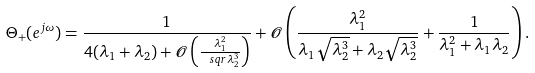Convert formula to latex. <formula><loc_0><loc_0><loc_500><loc_500>\Theta _ { + } ( e ^ { j \omega } ) = \frac { 1 } { 4 ( \lambda _ { 1 } + \lambda _ { 2 } ) + \mathcal { O } \left ( \frac { \lambda _ { 1 } ^ { 2 } } { \ s q r { \lambda _ { 2 } ^ { 3 } } } \right ) } + \mathcal { O } \left ( \frac { \lambda _ { 1 } ^ { 2 } } { \lambda _ { 1 } \sqrt { \lambda _ { 2 } ^ { 3 } } + \lambda _ { 2 } \sqrt { \lambda _ { 2 } ^ { 3 } } } + \frac { 1 } { \lambda _ { 1 } ^ { 2 } + \lambda _ { 1 } \lambda _ { 2 } } \right ) .</formula> 